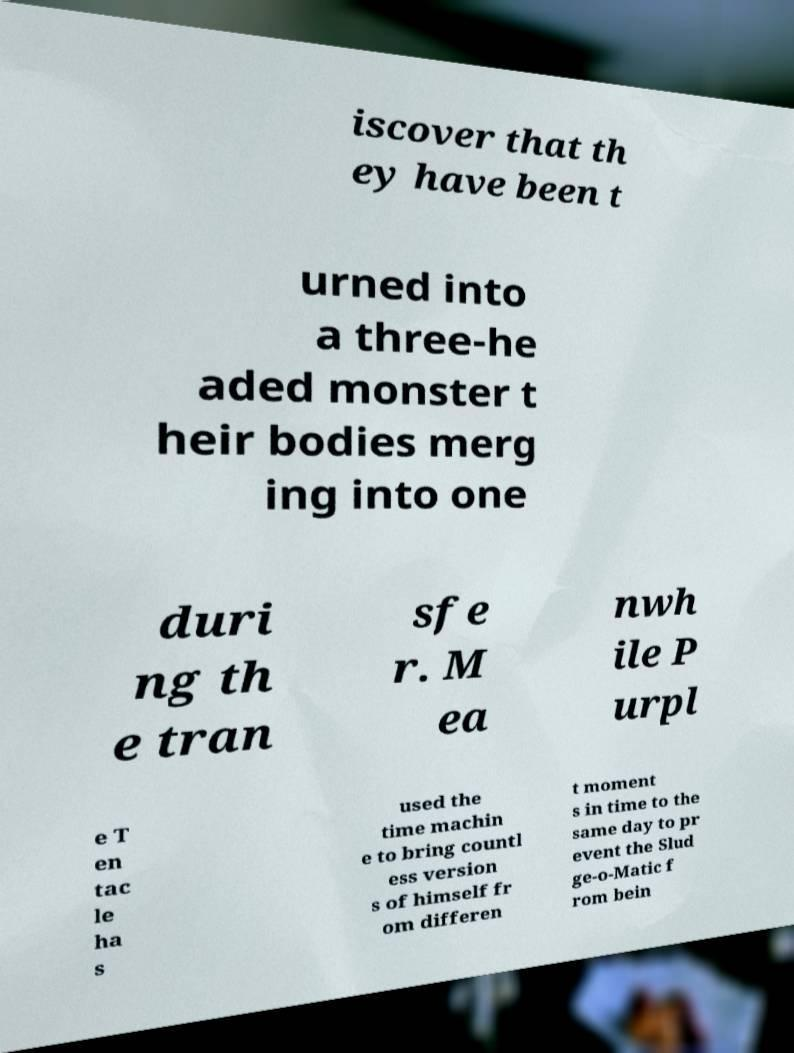Please read and relay the text visible in this image. What does it say? iscover that th ey have been t urned into a three-he aded monster t heir bodies merg ing into one duri ng th e tran sfe r. M ea nwh ile P urpl e T en tac le ha s used the time machin e to bring countl ess version s of himself fr om differen t moment s in time to the same day to pr event the Slud ge-o-Matic f rom bein 